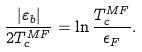Convert formula to latex. <formula><loc_0><loc_0><loc_500><loc_500>\frac { | \varepsilon _ { b } | } { 2 T _ { c } ^ { M F } } = \ln \frac { T _ { c } ^ { M F } } { \epsilon _ { F } } .</formula> 